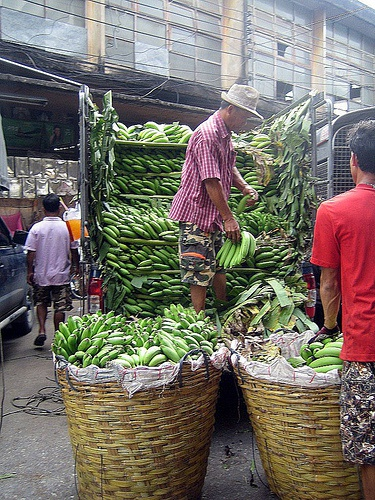Describe the objects in this image and their specific colors. I can see banana in lightgray, black, gray, darkgreen, and ivory tones, people in lightgray, brown, black, and gray tones, people in lightgray, gray, black, brown, and maroon tones, banana in lightgray, beige, black, darkgreen, and green tones, and people in lightgray, black, and gray tones in this image. 